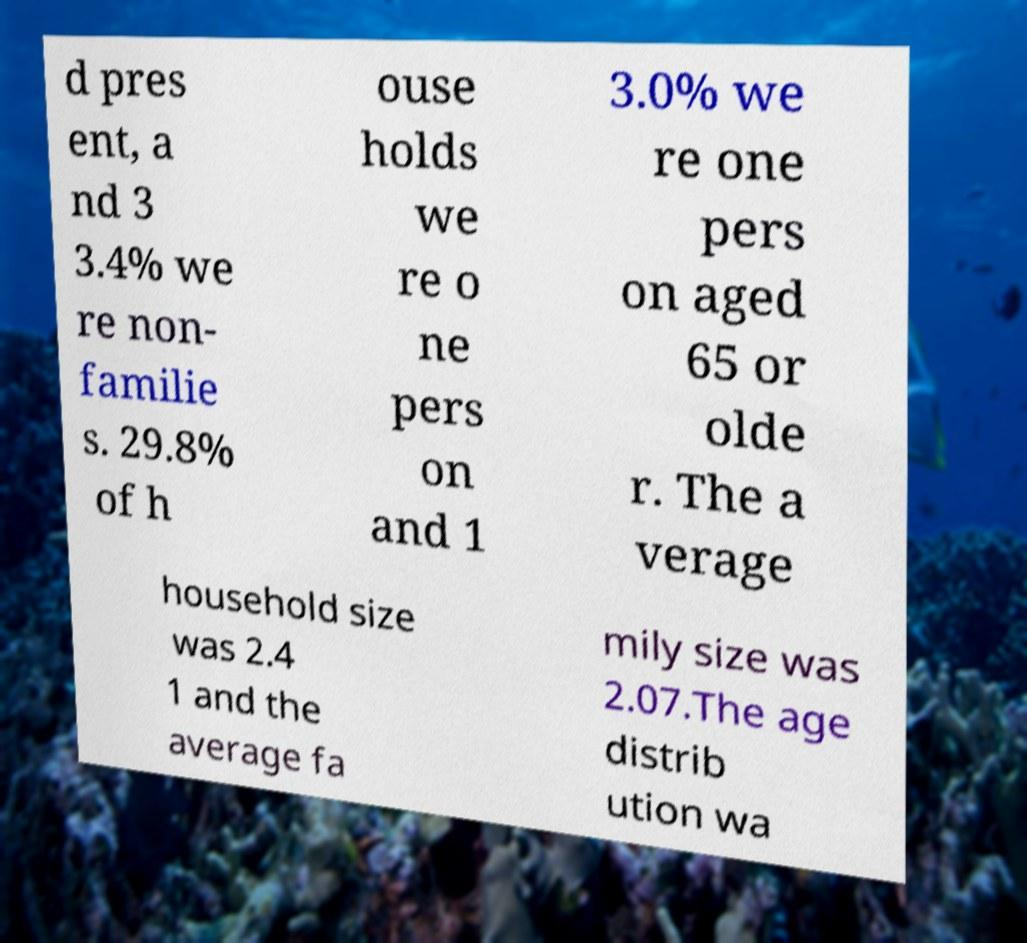Could you extract and type out the text from this image? d pres ent, a nd 3 3.4% we re non- familie s. 29.8% of h ouse holds we re o ne pers on and 1 3.0% we re one pers on aged 65 or olde r. The a verage household size was 2.4 1 and the average fa mily size was 2.07.The age distrib ution wa 